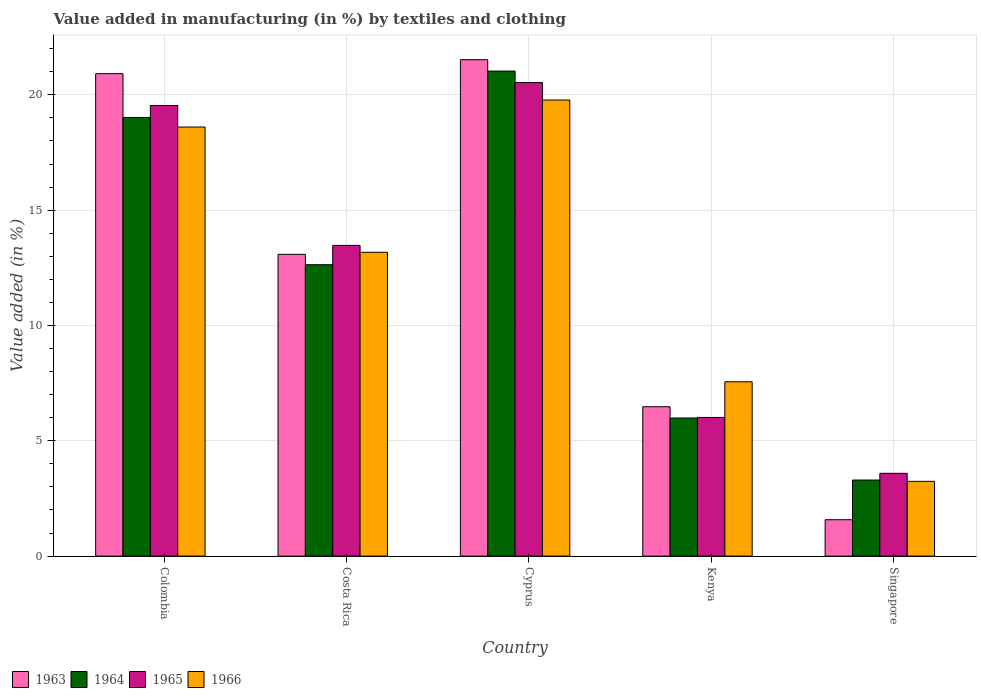How many different coloured bars are there?
Your response must be concise. 4. Are the number of bars per tick equal to the number of legend labels?
Your answer should be compact. Yes. How many bars are there on the 4th tick from the left?
Keep it short and to the point. 4. What is the label of the 4th group of bars from the left?
Offer a terse response. Kenya. What is the percentage of value added in manufacturing by textiles and clothing in 1964 in Kenya?
Provide a succinct answer. 5.99. Across all countries, what is the maximum percentage of value added in manufacturing by textiles and clothing in 1965?
Your answer should be compact. 20.53. Across all countries, what is the minimum percentage of value added in manufacturing by textiles and clothing in 1964?
Provide a short and direct response. 3.3. In which country was the percentage of value added in manufacturing by textiles and clothing in 1964 maximum?
Keep it short and to the point. Cyprus. In which country was the percentage of value added in manufacturing by textiles and clothing in 1966 minimum?
Make the answer very short. Singapore. What is the total percentage of value added in manufacturing by textiles and clothing in 1965 in the graph?
Provide a short and direct response. 63.14. What is the difference between the percentage of value added in manufacturing by textiles and clothing in 1966 in Costa Rica and that in Kenya?
Your answer should be very brief. 5.62. What is the difference between the percentage of value added in manufacturing by textiles and clothing in 1964 in Kenya and the percentage of value added in manufacturing by textiles and clothing in 1963 in Costa Rica?
Give a very brief answer. -7.1. What is the average percentage of value added in manufacturing by textiles and clothing in 1965 per country?
Your response must be concise. 12.63. What is the difference between the percentage of value added in manufacturing by textiles and clothing of/in 1963 and percentage of value added in manufacturing by textiles and clothing of/in 1966 in Cyprus?
Provide a short and direct response. 1.75. In how many countries, is the percentage of value added in manufacturing by textiles and clothing in 1964 greater than 12 %?
Ensure brevity in your answer.  3. What is the ratio of the percentage of value added in manufacturing by textiles and clothing in 1965 in Colombia to that in Kenya?
Keep it short and to the point. 3.25. Is the difference between the percentage of value added in manufacturing by textiles and clothing in 1963 in Costa Rica and Cyprus greater than the difference between the percentage of value added in manufacturing by textiles and clothing in 1966 in Costa Rica and Cyprus?
Make the answer very short. No. What is the difference between the highest and the second highest percentage of value added in manufacturing by textiles and clothing in 1964?
Your response must be concise. 6.38. What is the difference between the highest and the lowest percentage of value added in manufacturing by textiles and clothing in 1963?
Make the answer very short. 19.95. Is the sum of the percentage of value added in manufacturing by textiles and clothing in 1963 in Costa Rica and Cyprus greater than the maximum percentage of value added in manufacturing by textiles and clothing in 1965 across all countries?
Your answer should be compact. Yes. Is it the case that in every country, the sum of the percentage of value added in manufacturing by textiles and clothing in 1965 and percentage of value added in manufacturing by textiles and clothing in 1963 is greater than the sum of percentage of value added in manufacturing by textiles and clothing in 1966 and percentage of value added in manufacturing by textiles and clothing in 1964?
Give a very brief answer. No. What does the 4th bar from the left in Singapore represents?
Keep it short and to the point. 1966. What does the 1st bar from the right in Costa Rica represents?
Make the answer very short. 1966. Are all the bars in the graph horizontal?
Keep it short and to the point. No. What is the difference between two consecutive major ticks on the Y-axis?
Keep it short and to the point. 5. Are the values on the major ticks of Y-axis written in scientific E-notation?
Keep it short and to the point. No. How many legend labels are there?
Keep it short and to the point. 4. What is the title of the graph?
Make the answer very short. Value added in manufacturing (in %) by textiles and clothing. What is the label or title of the Y-axis?
Ensure brevity in your answer.  Value added (in %). What is the Value added (in %) of 1963 in Colombia?
Provide a short and direct response. 20.92. What is the Value added (in %) in 1964 in Colombia?
Provide a short and direct response. 19.02. What is the Value added (in %) of 1965 in Colombia?
Your answer should be compact. 19.54. What is the Value added (in %) of 1966 in Colombia?
Ensure brevity in your answer.  18.6. What is the Value added (in %) in 1963 in Costa Rica?
Keep it short and to the point. 13.08. What is the Value added (in %) in 1964 in Costa Rica?
Provide a short and direct response. 12.63. What is the Value added (in %) of 1965 in Costa Rica?
Provide a succinct answer. 13.47. What is the Value added (in %) in 1966 in Costa Rica?
Your answer should be compact. 13.17. What is the Value added (in %) in 1963 in Cyprus?
Provide a succinct answer. 21.52. What is the Value added (in %) of 1964 in Cyprus?
Offer a very short reply. 21.03. What is the Value added (in %) in 1965 in Cyprus?
Offer a very short reply. 20.53. What is the Value added (in %) of 1966 in Cyprus?
Your answer should be compact. 19.78. What is the Value added (in %) in 1963 in Kenya?
Your response must be concise. 6.48. What is the Value added (in %) of 1964 in Kenya?
Provide a succinct answer. 5.99. What is the Value added (in %) of 1965 in Kenya?
Provide a short and direct response. 6.01. What is the Value added (in %) of 1966 in Kenya?
Offer a very short reply. 7.56. What is the Value added (in %) in 1963 in Singapore?
Ensure brevity in your answer.  1.58. What is the Value added (in %) in 1964 in Singapore?
Offer a very short reply. 3.3. What is the Value added (in %) in 1965 in Singapore?
Provide a succinct answer. 3.59. What is the Value added (in %) in 1966 in Singapore?
Offer a terse response. 3.24. Across all countries, what is the maximum Value added (in %) of 1963?
Offer a terse response. 21.52. Across all countries, what is the maximum Value added (in %) of 1964?
Keep it short and to the point. 21.03. Across all countries, what is the maximum Value added (in %) of 1965?
Offer a very short reply. 20.53. Across all countries, what is the maximum Value added (in %) of 1966?
Give a very brief answer. 19.78. Across all countries, what is the minimum Value added (in %) in 1963?
Offer a very short reply. 1.58. Across all countries, what is the minimum Value added (in %) of 1964?
Provide a short and direct response. 3.3. Across all countries, what is the minimum Value added (in %) of 1965?
Keep it short and to the point. 3.59. Across all countries, what is the minimum Value added (in %) in 1966?
Offer a very short reply. 3.24. What is the total Value added (in %) in 1963 in the graph?
Your response must be concise. 63.58. What is the total Value added (in %) of 1964 in the graph?
Provide a short and direct response. 61.97. What is the total Value added (in %) of 1965 in the graph?
Offer a terse response. 63.14. What is the total Value added (in %) in 1966 in the graph?
Your response must be concise. 62.35. What is the difference between the Value added (in %) of 1963 in Colombia and that in Costa Rica?
Offer a terse response. 7.83. What is the difference between the Value added (in %) of 1964 in Colombia and that in Costa Rica?
Your response must be concise. 6.38. What is the difference between the Value added (in %) in 1965 in Colombia and that in Costa Rica?
Provide a short and direct response. 6.06. What is the difference between the Value added (in %) of 1966 in Colombia and that in Costa Rica?
Give a very brief answer. 5.43. What is the difference between the Value added (in %) of 1963 in Colombia and that in Cyprus?
Make the answer very short. -0.61. What is the difference between the Value added (in %) of 1964 in Colombia and that in Cyprus?
Ensure brevity in your answer.  -2.01. What is the difference between the Value added (in %) of 1965 in Colombia and that in Cyprus?
Your answer should be compact. -0.99. What is the difference between the Value added (in %) of 1966 in Colombia and that in Cyprus?
Offer a terse response. -1.17. What is the difference between the Value added (in %) in 1963 in Colombia and that in Kenya?
Offer a terse response. 14.44. What is the difference between the Value added (in %) in 1964 in Colombia and that in Kenya?
Ensure brevity in your answer.  13.03. What is the difference between the Value added (in %) of 1965 in Colombia and that in Kenya?
Ensure brevity in your answer.  13.53. What is the difference between the Value added (in %) of 1966 in Colombia and that in Kenya?
Give a very brief answer. 11.05. What is the difference between the Value added (in %) of 1963 in Colombia and that in Singapore?
Provide a short and direct response. 19.34. What is the difference between the Value added (in %) in 1964 in Colombia and that in Singapore?
Your response must be concise. 15.72. What is the difference between the Value added (in %) in 1965 in Colombia and that in Singapore?
Make the answer very short. 15.95. What is the difference between the Value added (in %) of 1966 in Colombia and that in Singapore?
Your answer should be very brief. 15.36. What is the difference between the Value added (in %) of 1963 in Costa Rica and that in Cyprus?
Keep it short and to the point. -8.44. What is the difference between the Value added (in %) in 1964 in Costa Rica and that in Cyprus?
Provide a succinct answer. -8.4. What is the difference between the Value added (in %) of 1965 in Costa Rica and that in Cyprus?
Keep it short and to the point. -7.06. What is the difference between the Value added (in %) of 1966 in Costa Rica and that in Cyprus?
Make the answer very short. -6.6. What is the difference between the Value added (in %) in 1963 in Costa Rica and that in Kenya?
Your response must be concise. 6.61. What is the difference between the Value added (in %) of 1964 in Costa Rica and that in Kenya?
Give a very brief answer. 6.65. What is the difference between the Value added (in %) of 1965 in Costa Rica and that in Kenya?
Keep it short and to the point. 7.46. What is the difference between the Value added (in %) in 1966 in Costa Rica and that in Kenya?
Your answer should be compact. 5.62. What is the difference between the Value added (in %) in 1963 in Costa Rica and that in Singapore?
Provide a short and direct response. 11.51. What is the difference between the Value added (in %) in 1964 in Costa Rica and that in Singapore?
Your answer should be compact. 9.34. What is the difference between the Value added (in %) in 1965 in Costa Rica and that in Singapore?
Offer a terse response. 9.88. What is the difference between the Value added (in %) in 1966 in Costa Rica and that in Singapore?
Provide a short and direct response. 9.93. What is the difference between the Value added (in %) of 1963 in Cyprus and that in Kenya?
Your answer should be very brief. 15.05. What is the difference between the Value added (in %) in 1964 in Cyprus and that in Kenya?
Your answer should be compact. 15.04. What is the difference between the Value added (in %) of 1965 in Cyprus and that in Kenya?
Ensure brevity in your answer.  14.52. What is the difference between the Value added (in %) of 1966 in Cyprus and that in Kenya?
Your answer should be compact. 12.22. What is the difference between the Value added (in %) of 1963 in Cyprus and that in Singapore?
Offer a terse response. 19.95. What is the difference between the Value added (in %) of 1964 in Cyprus and that in Singapore?
Your answer should be very brief. 17.73. What is the difference between the Value added (in %) of 1965 in Cyprus and that in Singapore?
Your answer should be compact. 16.94. What is the difference between the Value added (in %) of 1966 in Cyprus and that in Singapore?
Ensure brevity in your answer.  16.53. What is the difference between the Value added (in %) in 1963 in Kenya and that in Singapore?
Provide a succinct answer. 4.9. What is the difference between the Value added (in %) in 1964 in Kenya and that in Singapore?
Provide a short and direct response. 2.69. What is the difference between the Value added (in %) of 1965 in Kenya and that in Singapore?
Your answer should be very brief. 2.42. What is the difference between the Value added (in %) in 1966 in Kenya and that in Singapore?
Your response must be concise. 4.32. What is the difference between the Value added (in %) of 1963 in Colombia and the Value added (in %) of 1964 in Costa Rica?
Provide a succinct answer. 8.28. What is the difference between the Value added (in %) in 1963 in Colombia and the Value added (in %) in 1965 in Costa Rica?
Your answer should be compact. 7.44. What is the difference between the Value added (in %) in 1963 in Colombia and the Value added (in %) in 1966 in Costa Rica?
Keep it short and to the point. 7.74. What is the difference between the Value added (in %) in 1964 in Colombia and the Value added (in %) in 1965 in Costa Rica?
Offer a terse response. 5.55. What is the difference between the Value added (in %) of 1964 in Colombia and the Value added (in %) of 1966 in Costa Rica?
Provide a succinct answer. 5.84. What is the difference between the Value added (in %) in 1965 in Colombia and the Value added (in %) in 1966 in Costa Rica?
Provide a succinct answer. 6.36. What is the difference between the Value added (in %) of 1963 in Colombia and the Value added (in %) of 1964 in Cyprus?
Offer a terse response. -0.11. What is the difference between the Value added (in %) of 1963 in Colombia and the Value added (in %) of 1965 in Cyprus?
Give a very brief answer. 0.39. What is the difference between the Value added (in %) of 1963 in Colombia and the Value added (in %) of 1966 in Cyprus?
Offer a very short reply. 1.14. What is the difference between the Value added (in %) in 1964 in Colombia and the Value added (in %) in 1965 in Cyprus?
Offer a very short reply. -1.51. What is the difference between the Value added (in %) of 1964 in Colombia and the Value added (in %) of 1966 in Cyprus?
Offer a terse response. -0.76. What is the difference between the Value added (in %) in 1965 in Colombia and the Value added (in %) in 1966 in Cyprus?
Your answer should be very brief. -0.24. What is the difference between the Value added (in %) in 1963 in Colombia and the Value added (in %) in 1964 in Kenya?
Provide a short and direct response. 14.93. What is the difference between the Value added (in %) of 1963 in Colombia and the Value added (in %) of 1965 in Kenya?
Offer a very short reply. 14.91. What is the difference between the Value added (in %) in 1963 in Colombia and the Value added (in %) in 1966 in Kenya?
Ensure brevity in your answer.  13.36. What is the difference between the Value added (in %) of 1964 in Colombia and the Value added (in %) of 1965 in Kenya?
Your response must be concise. 13.01. What is the difference between the Value added (in %) of 1964 in Colombia and the Value added (in %) of 1966 in Kenya?
Give a very brief answer. 11.46. What is the difference between the Value added (in %) of 1965 in Colombia and the Value added (in %) of 1966 in Kenya?
Provide a succinct answer. 11.98. What is the difference between the Value added (in %) of 1963 in Colombia and the Value added (in %) of 1964 in Singapore?
Offer a very short reply. 17.62. What is the difference between the Value added (in %) in 1963 in Colombia and the Value added (in %) in 1965 in Singapore?
Give a very brief answer. 17.33. What is the difference between the Value added (in %) in 1963 in Colombia and the Value added (in %) in 1966 in Singapore?
Give a very brief answer. 17.68. What is the difference between the Value added (in %) in 1964 in Colombia and the Value added (in %) in 1965 in Singapore?
Provide a short and direct response. 15.43. What is the difference between the Value added (in %) of 1964 in Colombia and the Value added (in %) of 1966 in Singapore?
Give a very brief answer. 15.78. What is the difference between the Value added (in %) of 1965 in Colombia and the Value added (in %) of 1966 in Singapore?
Offer a very short reply. 16.3. What is the difference between the Value added (in %) in 1963 in Costa Rica and the Value added (in %) in 1964 in Cyprus?
Provide a succinct answer. -7.95. What is the difference between the Value added (in %) in 1963 in Costa Rica and the Value added (in %) in 1965 in Cyprus?
Provide a short and direct response. -7.45. What is the difference between the Value added (in %) of 1963 in Costa Rica and the Value added (in %) of 1966 in Cyprus?
Ensure brevity in your answer.  -6.69. What is the difference between the Value added (in %) of 1964 in Costa Rica and the Value added (in %) of 1965 in Cyprus?
Your answer should be very brief. -7.9. What is the difference between the Value added (in %) of 1964 in Costa Rica and the Value added (in %) of 1966 in Cyprus?
Offer a very short reply. -7.14. What is the difference between the Value added (in %) of 1965 in Costa Rica and the Value added (in %) of 1966 in Cyprus?
Provide a short and direct response. -6.3. What is the difference between the Value added (in %) of 1963 in Costa Rica and the Value added (in %) of 1964 in Kenya?
Your answer should be very brief. 7.1. What is the difference between the Value added (in %) of 1963 in Costa Rica and the Value added (in %) of 1965 in Kenya?
Offer a very short reply. 7.07. What is the difference between the Value added (in %) in 1963 in Costa Rica and the Value added (in %) in 1966 in Kenya?
Your answer should be very brief. 5.53. What is the difference between the Value added (in %) in 1964 in Costa Rica and the Value added (in %) in 1965 in Kenya?
Your response must be concise. 6.62. What is the difference between the Value added (in %) of 1964 in Costa Rica and the Value added (in %) of 1966 in Kenya?
Make the answer very short. 5.08. What is the difference between the Value added (in %) of 1965 in Costa Rica and the Value added (in %) of 1966 in Kenya?
Offer a terse response. 5.91. What is the difference between the Value added (in %) in 1963 in Costa Rica and the Value added (in %) in 1964 in Singapore?
Offer a very short reply. 9.79. What is the difference between the Value added (in %) in 1963 in Costa Rica and the Value added (in %) in 1965 in Singapore?
Provide a short and direct response. 9.5. What is the difference between the Value added (in %) of 1963 in Costa Rica and the Value added (in %) of 1966 in Singapore?
Make the answer very short. 9.84. What is the difference between the Value added (in %) of 1964 in Costa Rica and the Value added (in %) of 1965 in Singapore?
Make the answer very short. 9.04. What is the difference between the Value added (in %) in 1964 in Costa Rica and the Value added (in %) in 1966 in Singapore?
Provide a succinct answer. 9.39. What is the difference between the Value added (in %) of 1965 in Costa Rica and the Value added (in %) of 1966 in Singapore?
Offer a very short reply. 10.23. What is the difference between the Value added (in %) in 1963 in Cyprus and the Value added (in %) in 1964 in Kenya?
Ensure brevity in your answer.  15.54. What is the difference between the Value added (in %) of 1963 in Cyprus and the Value added (in %) of 1965 in Kenya?
Ensure brevity in your answer.  15.51. What is the difference between the Value added (in %) in 1963 in Cyprus and the Value added (in %) in 1966 in Kenya?
Your response must be concise. 13.97. What is the difference between the Value added (in %) in 1964 in Cyprus and the Value added (in %) in 1965 in Kenya?
Your answer should be very brief. 15.02. What is the difference between the Value added (in %) in 1964 in Cyprus and the Value added (in %) in 1966 in Kenya?
Offer a terse response. 13.47. What is the difference between the Value added (in %) of 1965 in Cyprus and the Value added (in %) of 1966 in Kenya?
Give a very brief answer. 12.97. What is the difference between the Value added (in %) in 1963 in Cyprus and the Value added (in %) in 1964 in Singapore?
Ensure brevity in your answer.  18.23. What is the difference between the Value added (in %) in 1963 in Cyprus and the Value added (in %) in 1965 in Singapore?
Give a very brief answer. 17.93. What is the difference between the Value added (in %) in 1963 in Cyprus and the Value added (in %) in 1966 in Singapore?
Give a very brief answer. 18.28. What is the difference between the Value added (in %) of 1964 in Cyprus and the Value added (in %) of 1965 in Singapore?
Keep it short and to the point. 17.44. What is the difference between the Value added (in %) of 1964 in Cyprus and the Value added (in %) of 1966 in Singapore?
Make the answer very short. 17.79. What is the difference between the Value added (in %) in 1965 in Cyprus and the Value added (in %) in 1966 in Singapore?
Provide a short and direct response. 17.29. What is the difference between the Value added (in %) of 1963 in Kenya and the Value added (in %) of 1964 in Singapore?
Offer a very short reply. 3.18. What is the difference between the Value added (in %) of 1963 in Kenya and the Value added (in %) of 1965 in Singapore?
Your answer should be very brief. 2.89. What is the difference between the Value added (in %) in 1963 in Kenya and the Value added (in %) in 1966 in Singapore?
Keep it short and to the point. 3.24. What is the difference between the Value added (in %) in 1964 in Kenya and the Value added (in %) in 1965 in Singapore?
Ensure brevity in your answer.  2.4. What is the difference between the Value added (in %) in 1964 in Kenya and the Value added (in %) in 1966 in Singapore?
Ensure brevity in your answer.  2.75. What is the difference between the Value added (in %) in 1965 in Kenya and the Value added (in %) in 1966 in Singapore?
Offer a very short reply. 2.77. What is the average Value added (in %) in 1963 per country?
Provide a short and direct response. 12.72. What is the average Value added (in %) of 1964 per country?
Your response must be concise. 12.39. What is the average Value added (in %) in 1965 per country?
Offer a very short reply. 12.63. What is the average Value added (in %) of 1966 per country?
Your answer should be very brief. 12.47. What is the difference between the Value added (in %) of 1963 and Value added (in %) of 1964 in Colombia?
Make the answer very short. 1.9. What is the difference between the Value added (in %) of 1963 and Value added (in %) of 1965 in Colombia?
Offer a very short reply. 1.38. What is the difference between the Value added (in %) of 1963 and Value added (in %) of 1966 in Colombia?
Give a very brief answer. 2.31. What is the difference between the Value added (in %) in 1964 and Value added (in %) in 1965 in Colombia?
Make the answer very short. -0.52. What is the difference between the Value added (in %) in 1964 and Value added (in %) in 1966 in Colombia?
Keep it short and to the point. 0.41. What is the difference between the Value added (in %) in 1965 and Value added (in %) in 1966 in Colombia?
Your response must be concise. 0.93. What is the difference between the Value added (in %) in 1963 and Value added (in %) in 1964 in Costa Rica?
Provide a succinct answer. 0.45. What is the difference between the Value added (in %) of 1963 and Value added (in %) of 1965 in Costa Rica?
Offer a terse response. -0.39. What is the difference between the Value added (in %) of 1963 and Value added (in %) of 1966 in Costa Rica?
Make the answer very short. -0.09. What is the difference between the Value added (in %) in 1964 and Value added (in %) in 1965 in Costa Rica?
Offer a very short reply. -0.84. What is the difference between the Value added (in %) of 1964 and Value added (in %) of 1966 in Costa Rica?
Make the answer very short. -0.54. What is the difference between the Value added (in %) of 1965 and Value added (in %) of 1966 in Costa Rica?
Ensure brevity in your answer.  0.3. What is the difference between the Value added (in %) in 1963 and Value added (in %) in 1964 in Cyprus?
Offer a terse response. 0.49. What is the difference between the Value added (in %) in 1963 and Value added (in %) in 1965 in Cyprus?
Your answer should be very brief. 0.99. What is the difference between the Value added (in %) in 1963 and Value added (in %) in 1966 in Cyprus?
Your answer should be compact. 1.75. What is the difference between the Value added (in %) of 1964 and Value added (in %) of 1965 in Cyprus?
Ensure brevity in your answer.  0.5. What is the difference between the Value added (in %) in 1964 and Value added (in %) in 1966 in Cyprus?
Your answer should be very brief. 1.25. What is the difference between the Value added (in %) in 1965 and Value added (in %) in 1966 in Cyprus?
Offer a terse response. 0.76. What is the difference between the Value added (in %) in 1963 and Value added (in %) in 1964 in Kenya?
Give a very brief answer. 0.49. What is the difference between the Value added (in %) in 1963 and Value added (in %) in 1965 in Kenya?
Ensure brevity in your answer.  0.47. What is the difference between the Value added (in %) in 1963 and Value added (in %) in 1966 in Kenya?
Your response must be concise. -1.08. What is the difference between the Value added (in %) of 1964 and Value added (in %) of 1965 in Kenya?
Keep it short and to the point. -0.02. What is the difference between the Value added (in %) in 1964 and Value added (in %) in 1966 in Kenya?
Your answer should be very brief. -1.57. What is the difference between the Value added (in %) in 1965 and Value added (in %) in 1966 in Kenya?
Your answer should be compact. -1.55. What is the difference between the Value added (in %) of 1963 and Value added (in %) of 1964 in Singapore?
Ensure brevity in your answer.  -1.72. What is the difference between the Value added (in %) in 1963 and Value added (in %) in 1965 in Singapore?
Your response must be concise. -2.01. What is the difference between the Value added (in %) in 1963 and Value added (in %) in 1966 in Singapore?
Provide a short and direct response. -1.66. What is the difference between the Value added (in %) in 1964 and Value added (in %) in 1965 in Singapore?
Give a very brief answer. -0.29. What is the difference between the Value added (in %) in 1964 and Value added (in %) in 1966 in Singapore?
Provide a short and direct response. 0.06. What is the difference between the Value added (in %) of 1965 and Value added (in %) of 1966 in Singapore?
Provide a succinct answer. 0.35. What is the ratio of the Value added (in %) of 1963 in Colombia to that in Costa Rica?
Keep it short and to the point. 1.6. What is the ratio of the Value added (in %) in 1964 in Colombia to that in Costa Rica?
Your response must be concise. 1.51. What is the ratio of the Value added (in %) of 1965 in Colombia to that in Costa Rica?
Your answer should be compact. 1.45. What is the ratio of the Value added (in %) of 1966 in Colombia to that in Costa Rica?
Provide a short and direct response. 1.41. What is the ratio of the Value added (in %) of 1963 in Colombia to that in Cyprus?
Make the answer very short. 0.97. What is the ratio of the Value added (in %) of 1964 in Colombia to that in Cyprus?
Offer a very short reply. 0.9. What is the ratio of the Value added (in %) in 1965 in Colombia to that in Cyprus?
Provide a short and direct response. 0.95. What is the ratio of the Value added (in %) of 1966 in Colombia to that in Cyprus?
Offer a very short reply. 0.94. What is the ratio of the Value added (in %) in 1963 in Colombia to that in Kenya?
Your response must be concise. 3.23. What is the ratio of the Value added (in %) of 1964 in Colombia to that in Kenya?
Provide a short and direct response. 3.18. What is the ratio of the Value added (in %) in 1965 in Colombia to that in Kenya?
Give a very brief answer. 3.25. What is the ratio of the Value added (in %) in 1966 in Colombia to that in Kenya?
Keep it short and to the point. 2.46. What is the ratio of the Value added (in %) in 1963 in Colombia to that in Singapore?
Your answer should be very brief. 13.26. What is the ratio of the Value added (in %) of 1964 in Colombia to that in Singapore?
Provide a short and direct response. 5.77. What is the ratio of the Value added (in %) of 1965 in Colombia to that in Singapore?
Provide a succinct answer. 5.44. What is the ratio of the Value added (in %) in 1966 in Colombia to that in Singapore?
Your answer should be very brief. 5.74. What is the ratio of the Value added (in %) in 1963 in Costa Rica to that in Cyprus?
Make the answer very short. 0.61. What is the ratio of the Value added (in %) of 1964 in Costa Rica to that in Cyprus?
Provide a succinct answer. 0.6. What is the ratio of the Value added (in %) of 1965 in Costa Rica to that in Cyprus?
Your response must be concise. 0.66. What is the ratio of the Value added (in %) of 1966 in Costa Rica to that in Cyprus?
Your answer should be very brief. 0.67. What is the ratio of the Value added (in %) of 1963 in Costa Rica to that in Kenya?
Your response must be concise. 2.02. What is the ratio of the Value added (in %) of 1964 in Costa Rica to that in Kenya?
Your answer should be compact. 2.11. What is the ratio of the Value added (in %) of 1965 in Costa Rica to that in Kenya?
Offer a very short reply. 2.24. What is the ratio of the Value added (in %) in 1966 in Costa Rica to that in Kenya?
Your response must be concise. 1.74. What is the ratio of the Value added (in %) in 1963 in Costa Rica to that in Singapore?
Ensure brevity in your answer.  8.3. What is the ratio of the Value added (in %) in 1964 in Costa Rica to that in Singapore?
Your response must be concise. 3.83. What is the ratio of the Value added (in %) of 1965 in Costa Rica to that in Singapore?
Your answer should be compact. 3.75. What is the ratio of the Value added (in %) in 1966 in Costa Rica to that in Singapore?
Provide a succinct answer. 4.06. What is the ratio of the Value added (in %) in 1963 in Cyprus to that in Kenya?
Offer a very short reply. 3.32. What is the ratio of the Value added (in %) of 1964 in Cyprus to that in Kenya?
Your response must be concise. 3.51. What is the ratio of the Value added (in %) of 1965 in Cyprus to that in Kenya?
Your response must be concise. 3.42. What is the ratio of the Value added (in %) in 1966 in Cyprus to that in Kenya?
Your response must be concise. 2.62. What is the ratio of the Value added (in %) of 1963 in Cyprus to that in Singapore?
Offer a very short reply. 13.65. What is the ratio of the Value added (in %) in 1964 in Cyprus to that in Singapore?
Offer a terse response. 6.38. What is the ratio of the Value added (in %) in 1965 in Cyprus to that in Singapore?
Offer a terse response. 5.72. What is the ratio of the Value added (in %) in 1966 in Cyprus to that in Singapore?
Keep it short and to the point. 6.1. What is the ratio of the Value added (in %) in 1963 in Kenya to that in Singapore?
Give a very brief answer. 4.11. What is the ratio of the Value added (in %) in 1964 in Kenya to that in Singapore?
Provide a short and direct response. 1.82. What is the ratio of the Value added (in %) of 1965 in Kenya to that in Singapore?
Your response must be concise. 1.67. What is the ratio of the Value added (in %) of 1966 in Kenya to that in Singapore?
Your answer should be very brief. 2.33. What is the difference between the highest and the second highest Value added (in %) in 1963?
Ensure brevity in your answer.  0.61. What is the difference between the highest and the second highest Value added (in %) of 1964?
Your answer should be very brief. 2.01. What is the difference between the highest and the second highest Value added (in %) in 1965?
Offer a terse response. 0.99. What is the difference between the highest and the second highest Value added (in %) of 1966?
Your response must be concise. 1.17. What is the difference between the highest and the lowest Value added (in %) in 1963?
Provide a succinct answer. 19.95. What is the difference between the highest and the lowest Value added (in %) in 1964?
Provide a short and direct response. 17.73. What is the difference between the highest and the lowest Value added (in %) of 1965?
Offer a terse response. 16.94. What is the difference between the highest and the lowest Value added (in %) of 1966?
Your answer should be compact. 16.53. 